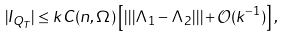<formula> <loc_0><loc_0><loc_500><loc_500>| I _ { Q _ { T } } | \leq k C ( n , \Omega ) \left [ | | | \Lambda _ { 1 } - \Lambda _ { 2 } | | | + \mathcal { O } ( k ^ { - 1 } ) \right ] ,</formula> 